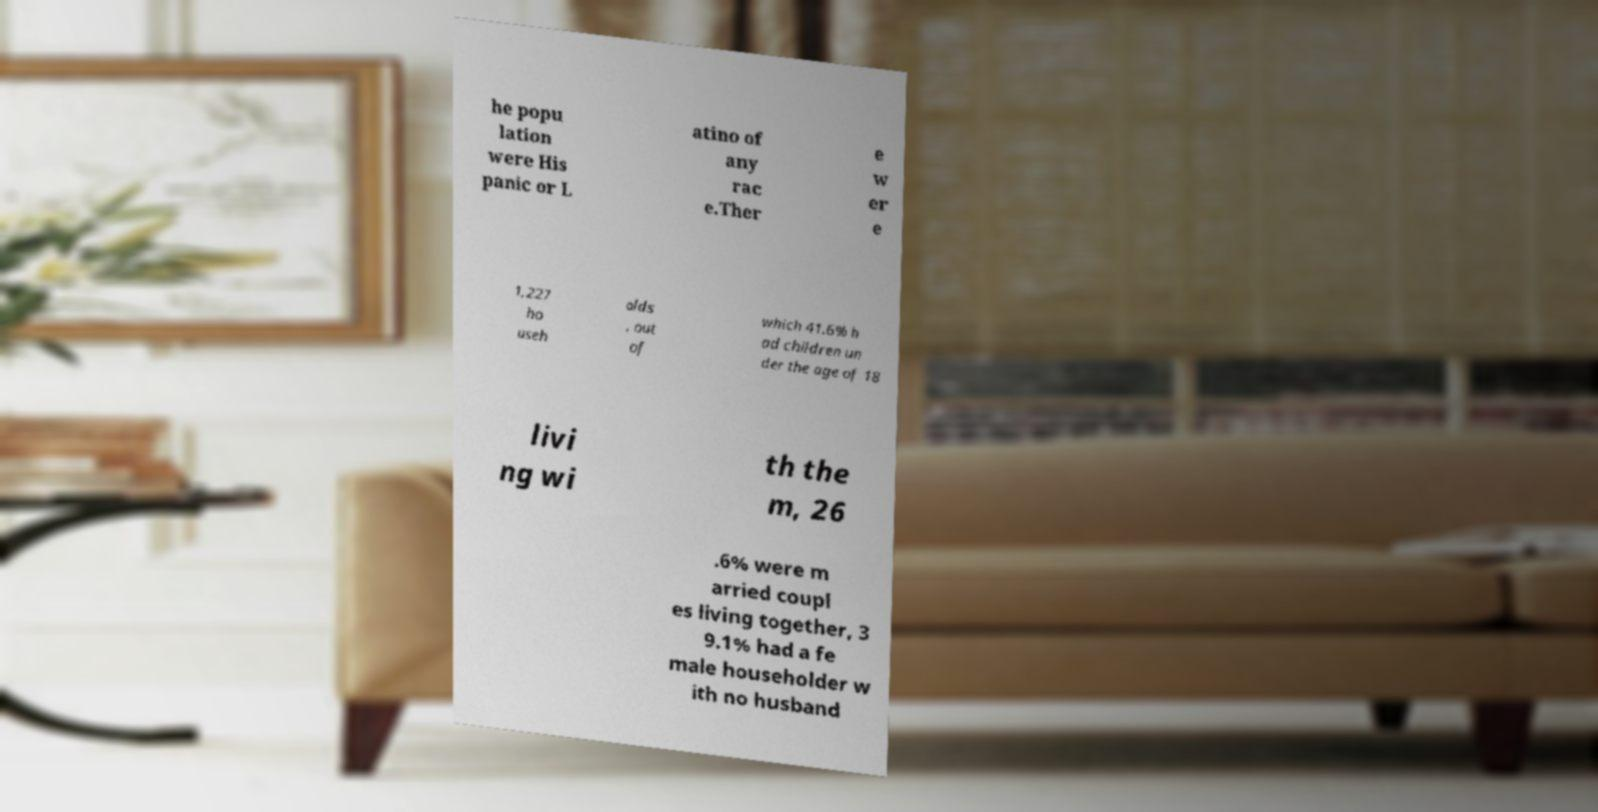Please identify and transcribe the text found in this image. he popu lation were His panic or L atino of any rac e.Ther e w er e 1,227 ho useh olds , out of which 41.6% h ad children un der the age of 18 livi ng wi th the m, 26 .6% were m arried coupl es living together, 3 9.1% had a fe male householder w ith no husband 